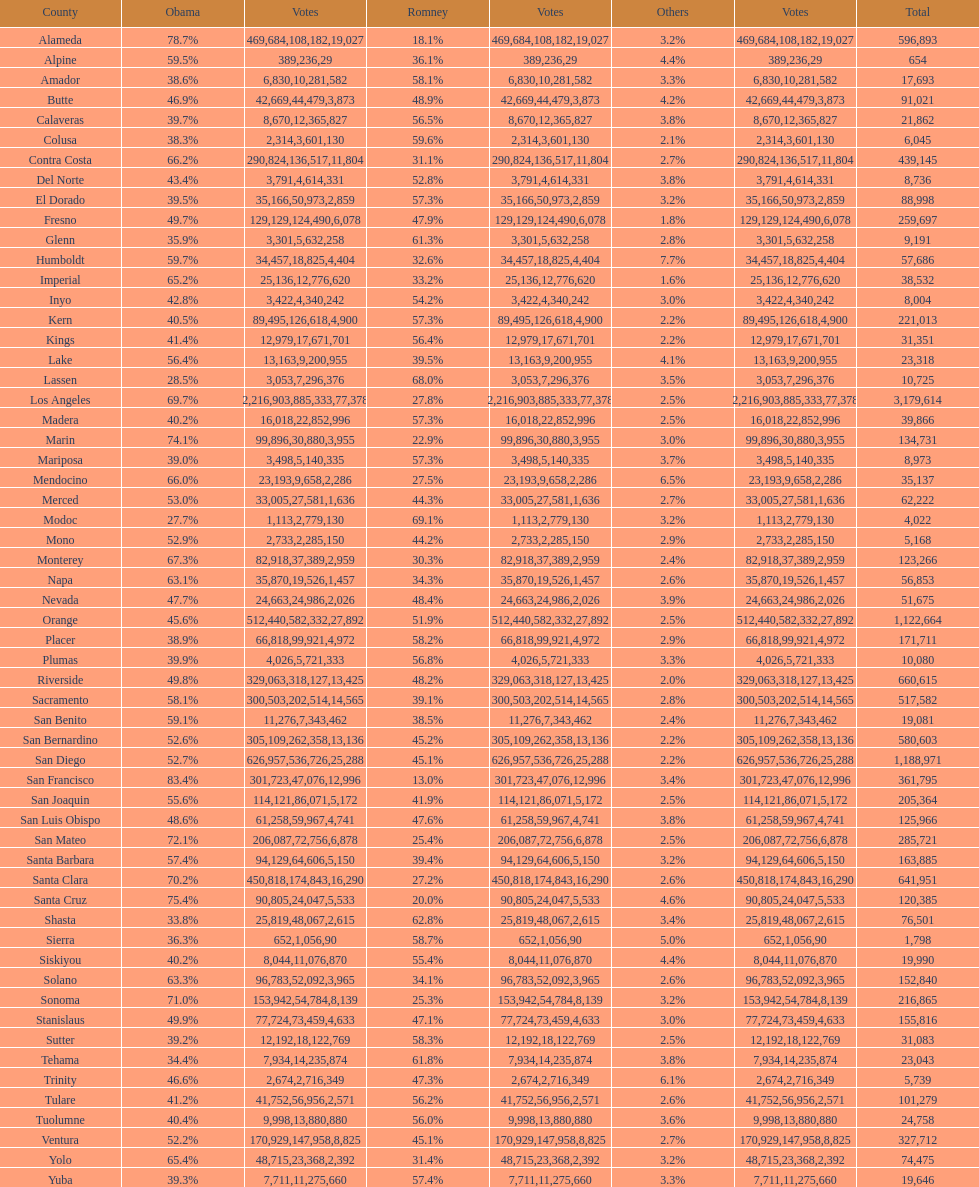In how many counties did obama secure 75% or above of the total votes? 3. 